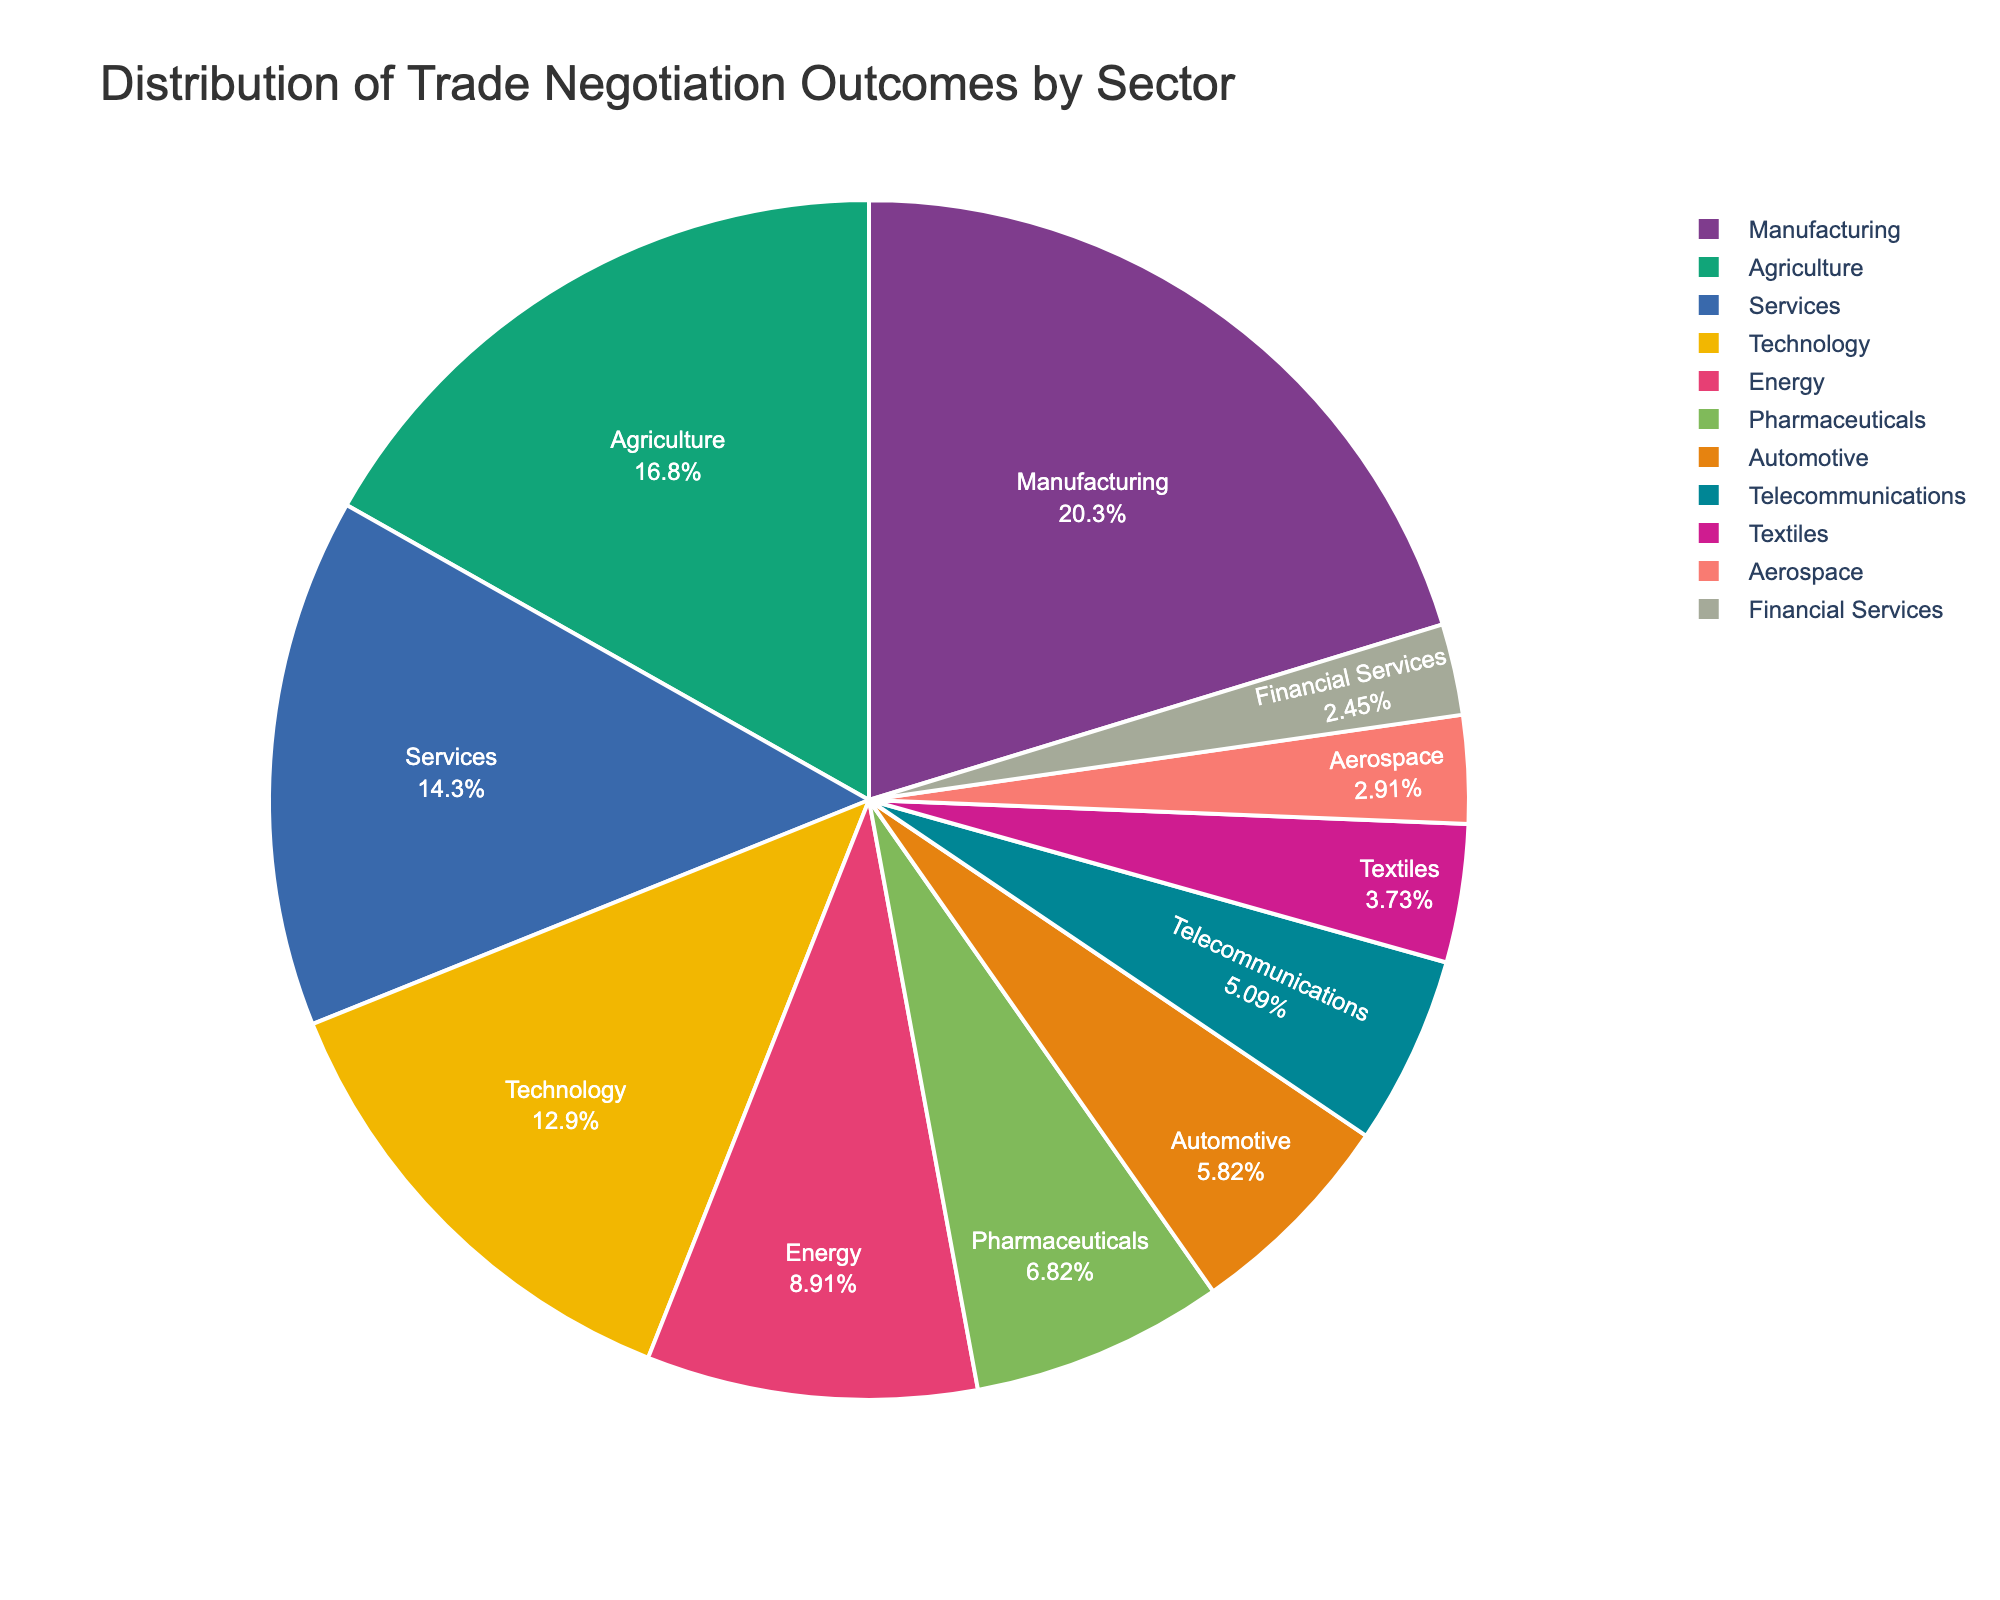What sector has the largest percentage of trade negotiation outcomes? Examine the pie chart and identify the sector with the largest slice. The sector with the highest percentage represents the largest proportion of outcomes.
Answer: Manufacturing How much larger is the Manufacturing sector compared to the Telecommunications sector? Find the percentages for both Manufacturing (22.3%) and Telecommunications (5.6%) in the pie chart, then subtract the Telecommunications percentage from the Manufacturing percentage: 22.3% - 5.6% = 16.7%
Answer: 16.7% What is the total percentage of trade negotiation outcomes for the Services and Technology sectors combined? Look at the pie chart to find the percentages for Services (15.7%) and Technology (14.2%). Add these percentages together: 15.7% + 14.2% = 29.9%
Answer: 29.9% Which sectors have percentages that are less than Pharmaceuticals? Identify the percentage for Pharmaceuticals (7.5%) and then compare it with the other sectors, noting those with smaller percentages. The sectors with less than 7.5% are Automotive (6.4%), Telecommunications (5.6%), Textiles (4.1%), Aerospace (3.2%), and Financial Services (2.7%).
Answer: Automotive, Telecommunications, Textiles, Aerospace, Financial Services What is the smallest sector by trade negotiation outcomes? Locate the smallest slice in the pie chart, which represents the sector with the lowest percentage.
Answer: Financial Services What is the average percentage of trade negotiation outcomes for the top three sectors? Identify the top three sectors by their percentages: Manufacturing (22.3%), Agriculture (18.5%), and Services (15.7%). Calculate the average by adding these percentages and dividing by three: (22.3% + 18.5% + 15.7%) / 3 = 18.83%
Answer: 18.83% How does the percentage of Agriculture compare to Technology? Find the percentages for Agriculture (18.5%) and Technology (14.2%) and subtract Technology from Agriculture: 18.5% - 14.2% = 4.3%
Answer: 4.3% larger Which sector is represented by a green slice in the pie chart? The pie chart uses a color palette to differentiate sectors. Identify the sector labeled with a green color (if specified in the color scheme). If not specified, this question may need visual verification.
Answer: Answer may vary If you combine the percentages of the four least significant sectors, what fraction of the total do they represent? The four least significant sectors by percentage are Aerospace (3.2%), Financial Services (2.7%), Textiles (4.1%), and Telecommunications (5.6%). Sum these percentages: 3.2% + 2.7% + 4.1% + 5.6% = 15.6%. Since the total is 100%, the fraction they represent is 15.6/100 = 0.156
Answer: 0.156 Which sector has about half the percentage of the Manufacturing sector? Find the percentage of the Manufacturing sector (22.3%) and then look for a sector with approximately half of that percentage. Half of 22.3% is 11.15%. The closest sector is Energy with 9.8%.
Answer: Energy 